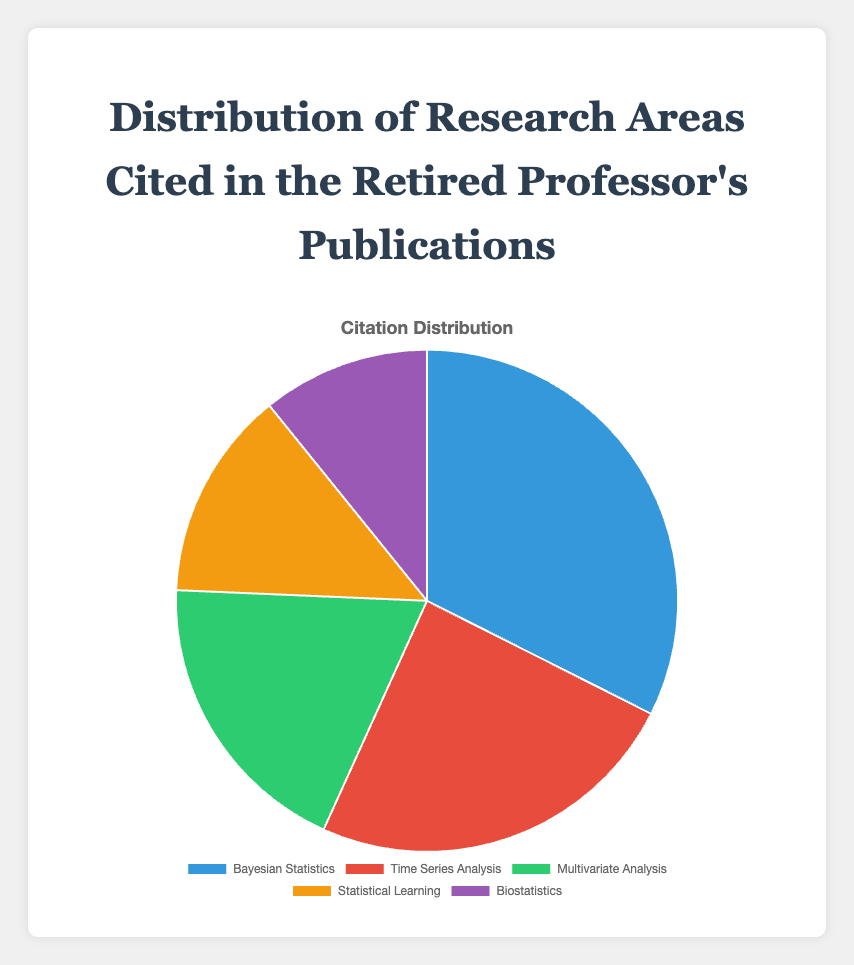Which research area has the highest citation count? The research area with the highest citation count can be determined by looking for the largest segment in the pie chart, which represents Bayesian Statistics with 120 citations.
Answer: Bayesian Statistics How many more citations does Bayesian Statistics have compared to Biostatistics? To find this, subtract the citation count of Biostatistics (40) from that of Bayesian Statistics (120). 120 - 40 = 80.
Answer: 80 What is the total number of citations across all research areas? Sum up all the citation counts: 120 (Bayesian Statistics) + 90 (Time Series Analysis) + 70 (Multivariate Analysis) + 50 (Statistical Learning) + 40 (Biostatistics) = 370.
Answer: 370 What percentage of the total citations does Time Series Analysis account for? Time Series Analysis has 90 citations. The total number of citations is 370. The percentage is (90 / 370) * 100 ≈ 24.32%.
Answer: ~24.32% Which research area has the smallest citation count? The smallest segment in the pie chart represents the research area with the smallest citation count, which is Biostatistics with 40 citations.
Answer: Biostatistics How does the citation count of Statistical Learning compare to that of Multivariate Analysis? Statistical Learning has 50 citations, whereas Multivariate Analysis has 70 citations. Since 50 is less than 70, Statistical Learning has fewer citations.
Answer: Statistical Learning has fewer citations What fraction of the total citations is attributable to Multivariate Analysis and Biostatistics combined? Multivariate Analysis has 70 citations, and Biostatistics has 40 citations. Their combined total is 70 + 40 = 110. The total number of citations is 370. The fraction is 110 / 370 = 11 / 37.
Answer: 11/37 If the citation count for Time Series Analysis increased by 10%, what would the new citation count be? A 10% increase in Time Series Analysis, which has 90 citations, is 90 * 0.10 = 9. The new citation count would be 90 + 9 = 99.
Answer: 99 Which color represents Multivariate Analysis in the chart? The pie chart uses color coding to represent different research areas. Multivariate Analysis is represented by the third color in the legend, which is green.
Answer: Green 